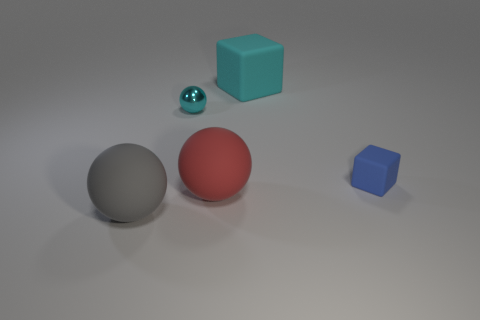Add 1 big red rubber objects. How many objects exist? 6 Subtract all balls. How many objects are left? 2 Subtract 0 red cylinders. How many objects are left? 5 Subtract all small cyan things. Subtract all small blue matte blocks. How many objects are left? 3 Add 5 blue cubes. How many blue cubes are left? 6 Add 3 small cyan balls. How many small cyan balls exist? 4 